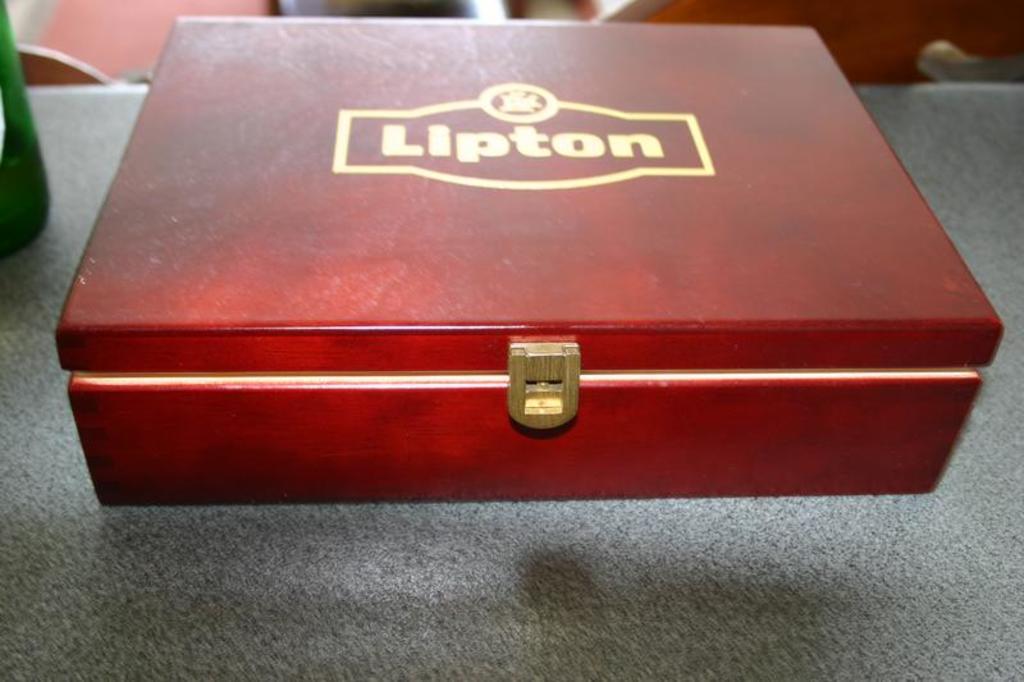What brand name is written on the box?
Give a very brief answer. Lipton. 